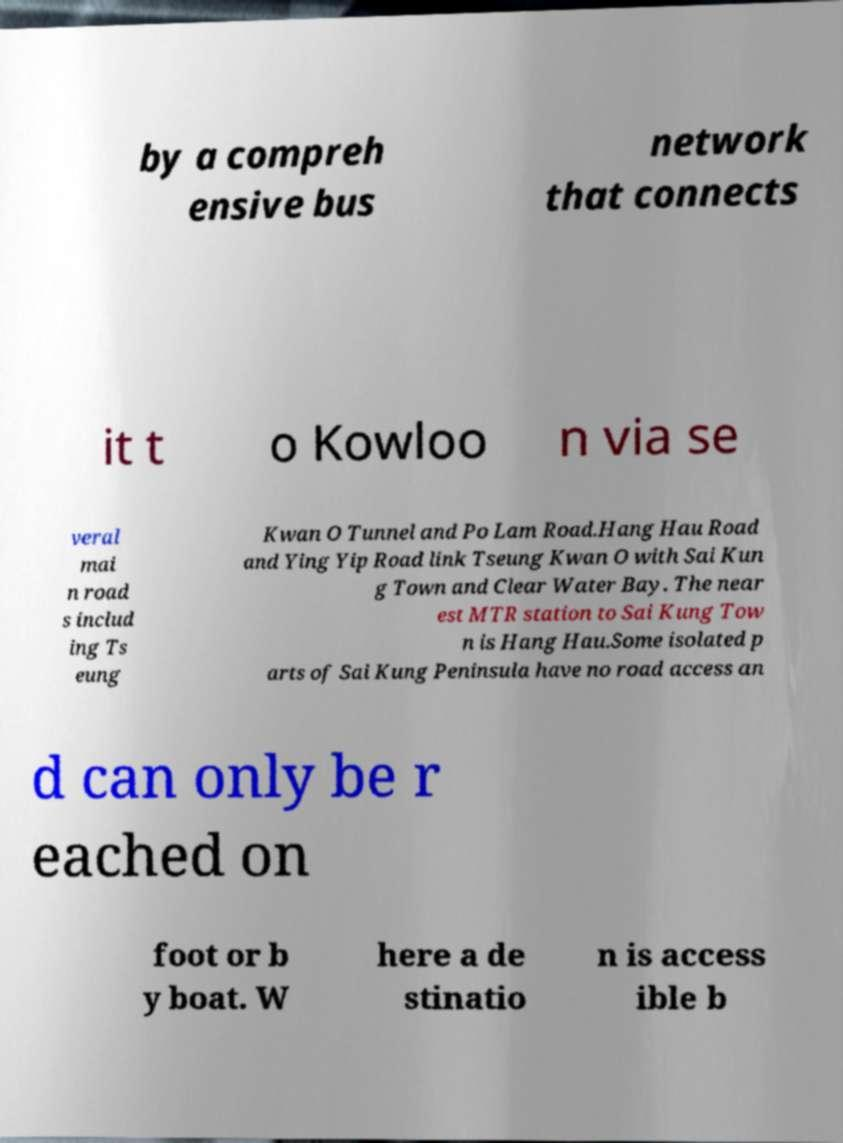Can you read and provide the text displayed in the image?This photo seems to have some interesting text. Can you extract and type it out for me? by a compreh ensive bus network that connects it t o Kowloo n via se veral mai n road s includ ing Ts eung Kwan O Tunnel and Po Lam Road.Hang Hau Road and Ying Yip Road link Tseung Kwan O with Sai Kun g Town and Clear Water Bay. The near est MTR station to Sai Kung Tow n is Hang Hau.Some isolated p arts of Sai Kung Peninsula have no road access an d can only be r eached on foot or b y boat. W here a de stinatio n is access ible b 